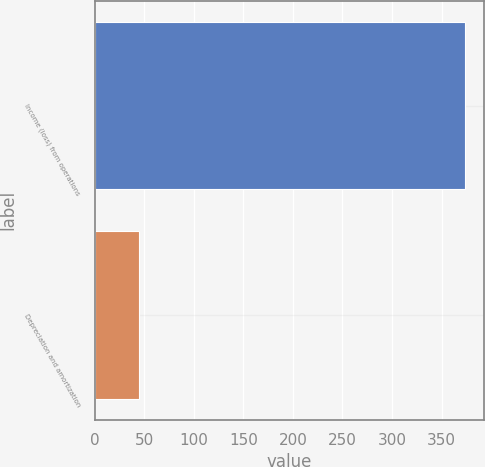Convert chart to OTSL. <chart><loc_0><loc_0><loc_500><loc_500><bar_chart><fcel>Income (loss) from operations<fcel>Depreciation and amortization<nl><fcel>374<fcel>44.8<nl></chart> 